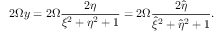<formula> <loc_0><loc_0><loc_500><loc_500>2 \Omega y = 2 \Omega \frac { 2 \eta } { \xi ^ { 2 } + \eta ^ { 2 } + 1 } = 2 \Omega \frac { 2 \hat { \eta } } { \hat { \xi } ^ { 2 } + \hat { \eta } ^ { 2 } + 1 } .</formula> 